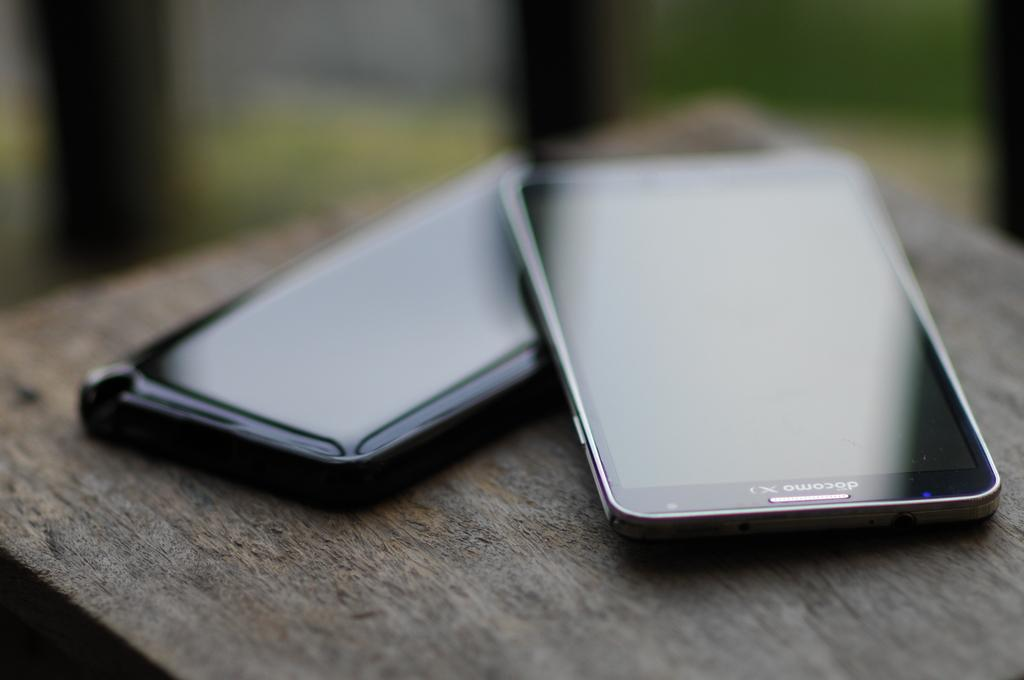<image>
Summarize the visual content of the image. Two phones sit on a table together, one is a docomo x. 